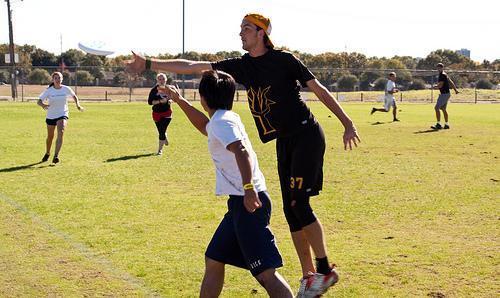How many people are visible in the picture?
Give a very brief answer. 6. 